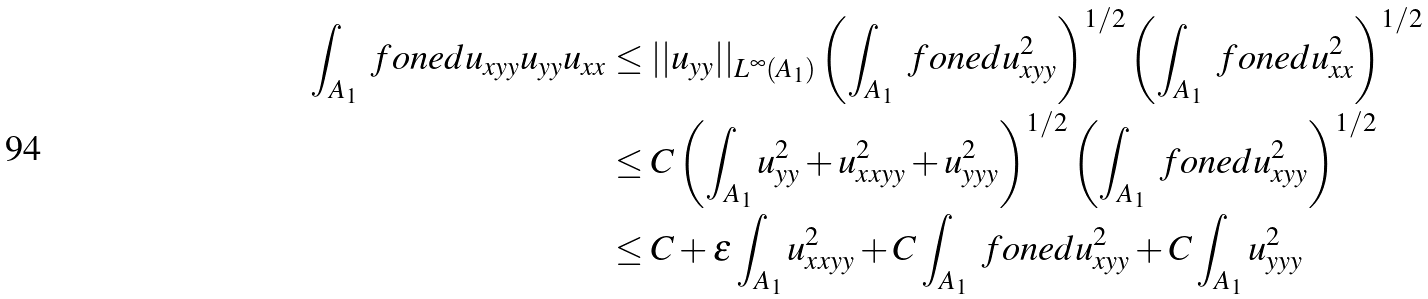<formula> <loc_0><loc_0><loc_500><loc_500>\int _ { A _ { 1 } } \ f o n e d u _ { x y y } u _ { y y } u _ { x x } & \leq | | u _ { y y } | | _ { L ^ { \infty } ( A _ { 1 } ) } \left ( \int _ { A _ { 1 } } \ f o n e d u _ { x y y } ^ { 2 } \right ) ^ { 1 / 2 } \left ( \int _ { A _ { 1 } } \ f o n e d u _ { x x } ^ { 2 } \right ) ^ { 1 / 2 } \\ & \leq C \left ( \int _ { A _ { 1 } } u _ { y y } ^ { 2 } + u _ { x x y y } ^ { 2 } + u _ { y y y } ^ { 2 } \right ) ^ { 1 / 2 } \left ( \int _ { A _ { 1 } } \ f o n e d u _ { x y y } ^ { 2 } \right ) ^ { 1 / 2 } \\ & \leq C + \epsilon \int _ { A _ { 1 } } u _ { x x y y } ^ { 2 } + C \int _ { A _ { 1 } } \ f o n e d u _ { x y y } ^ { 2 } + C \int _ { A _ { 1 } } u _ { y y y } ^ { 2 }</formula> 